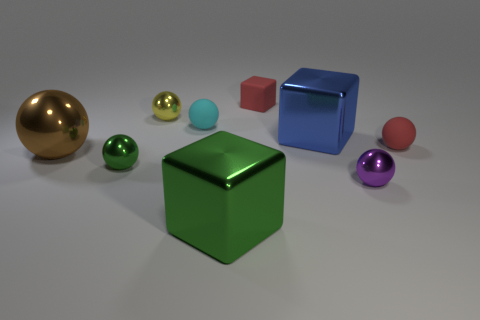How many things are either green metallic balls or large objects?
Keep it short and to the point. 4. What is the shape of the tiny purple object that is the same material as the yellow object?
Your answer should be very brief. Sphere. What number of tiny things are green spheres or blue metal cylinders?
Give a very brief answer. 1. What number of other things are there of the same color as the big metallic ball?
Your response must be concise. 0. What number of small purple metal objects are behind the shiny block that is behind the brown sphere on the left side of the blue metal cube?
Make the answer very short. 0. There is a green sphere that is in front of the blue cube; is its size the same as the cyan matte thing?
Ensure brevity in your answer.  Yes. Is the number of small balls that are to the right of the small yellow shiny thing less than the number of tiny purple shiny objects that are left of the brown metallic object?
Give a very brief answer. No. Do the tiny rubber block and the big ball have the same color?
Offer a terse response. No. Is the number of purple shiny things that are on the left side of the big blue metallic block less than the number of brown shiny cubes?
Give a very brief answer. No. There is a sphere that is the same color as the rubber cube; what is it made of?
Your answer should be compact. Rubber. 